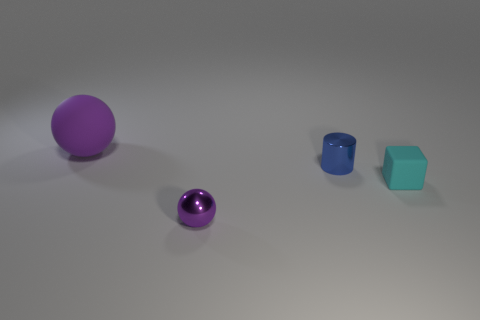Is there anything else that has the same shape as the tiny cyan object?
Provide a short and direct response. No. What material is the blue cylinder that is the same size as the cube?
Your answer should be compact. Metal. There is a tiny metal sphere that is on the right side of the big purple matte ball; what is its color?
Your answer should be very brief. Purple. What size is the thing that is both to the right of the purple shiny ball and left of the small cyan rubber cube?
Offer a very short reply. Small. Does the large thing have the same material as the purple object in front of the tiny blue metallic cylinder?
Make the answer very short. No. How many other purple objects have the same shape as the small purple thing?
Provide a short and direct response. 1. What is the material of the other ball that is the same color as the tiny sphere?
Your answer should be very brief. Rubber. What number of purple metallic balls are there?
Keep it short and to the point. 1. There is a cyan thing; does it have the same shape as the thing behind the small blue metallic thing?
Your response must be concise. No. What number of things are either tiny brown metal things or matte things in front of the big object?
Provide a short and direct response. 1. 